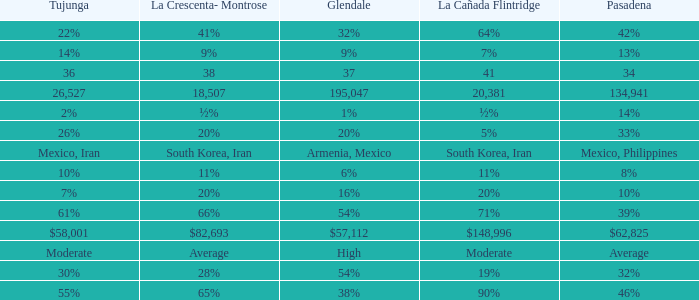What is the figure for Tujunga when Pasadena is 134,941? 26527.0. 